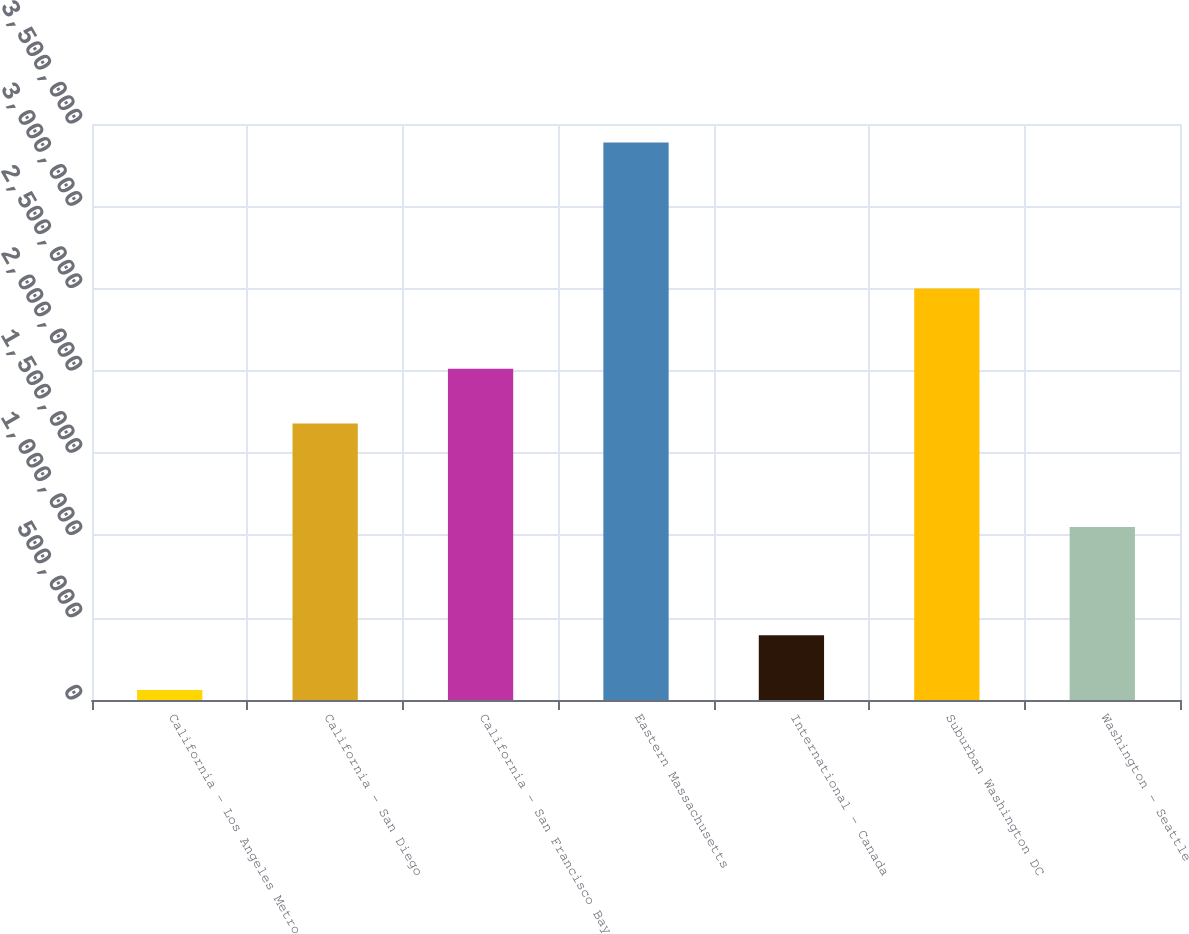<chart> <loc_0><loc_0><loc_500><loc_500><bar_chart><fcel>California - Los Angeles Metro<fcel>California - San Diego<fcel>California - San Francisco Bay<fcel>Eastern Massachusetts<fcel>International - Canada<fcel>Suburban Washington DC<fcel>Washington - Seattle<nl><fcel>61003<fcel>1.6804e+06<fcel>2.01301e+06<fcel>3.38704e+06<fcel>393606<fcel>2.49977e+06<fcel>1.0514e+06<nl></chart> 